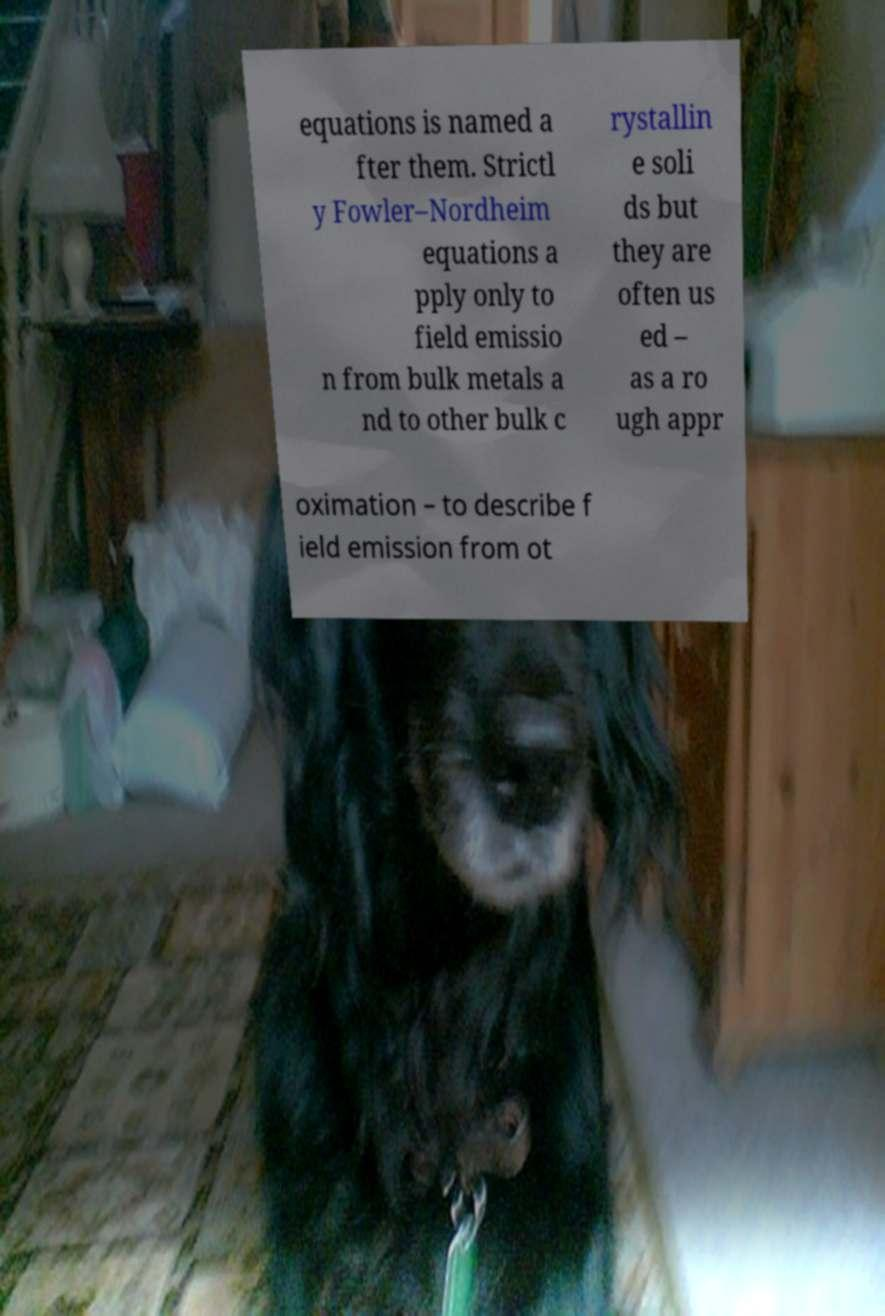For documentation purposes, I need the text within this image transcribed. Could you provide that? equations is named a fter them. Strictl y Fowler–Nordheim equations a pply only to field emissio n from bulk metals a nd to other bulk c rystallin e soli ds but they are often us ed – as a ro ugh appr oximation – to describe f ield emission from ot 